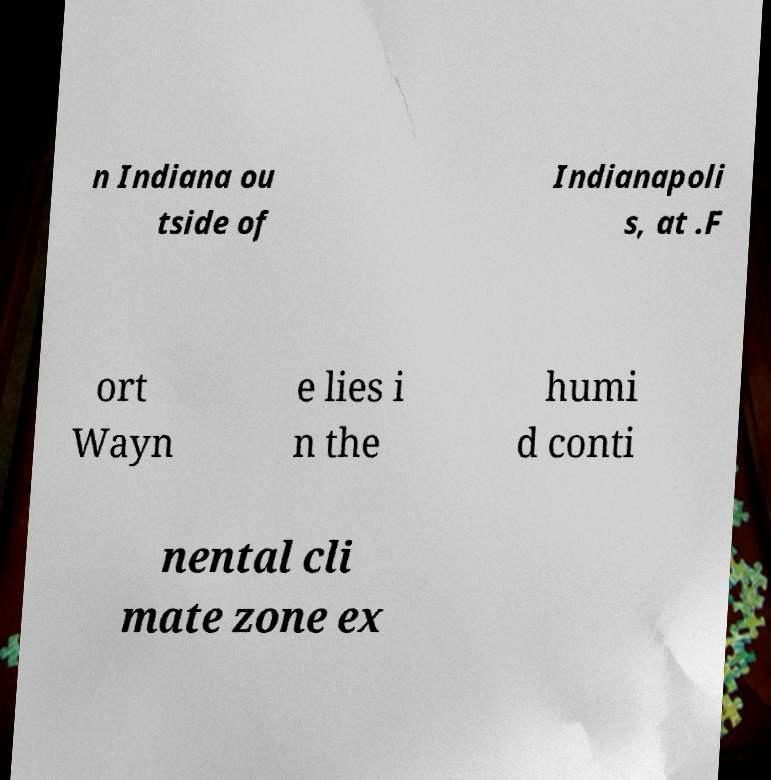I need the written content from this picture converted into text. Can you do that? n Indiana ou tside of Indianapoli s, at .F ort Wayn e lies i n the humi d conti nental cli mate zone ex 